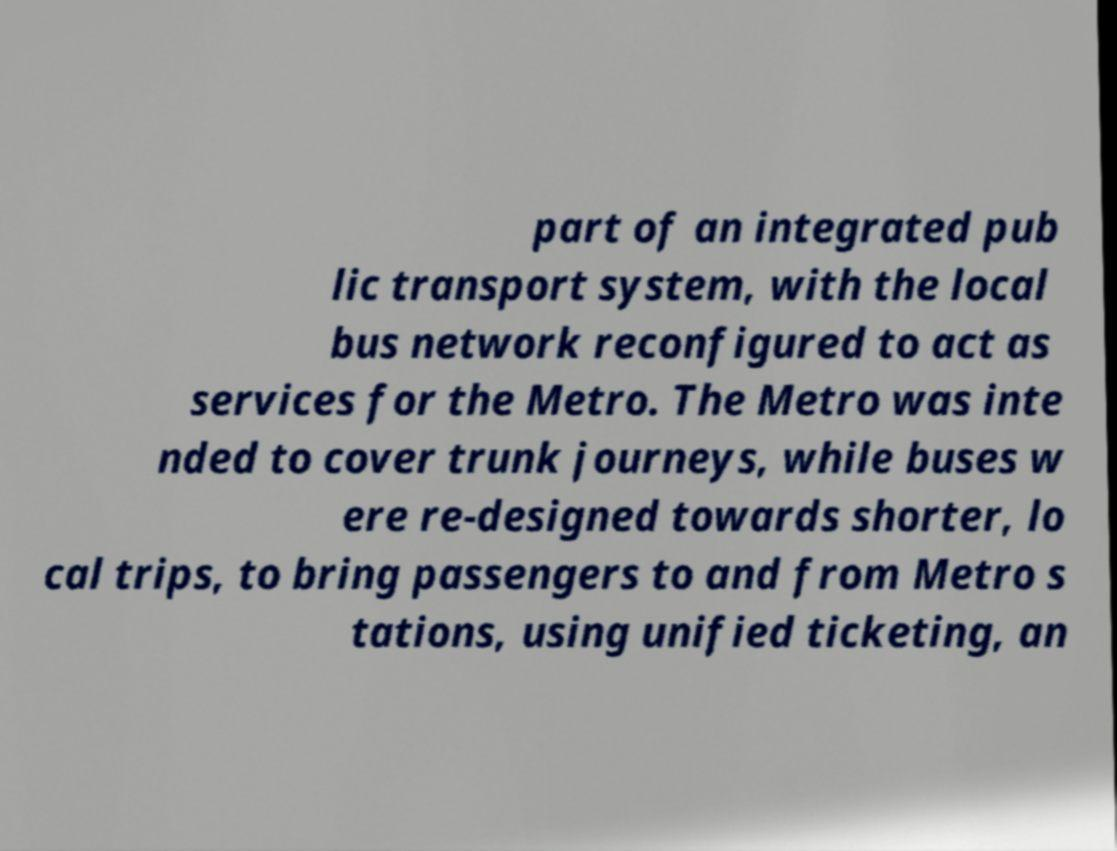There's text embedded in this image that I need extracted. Can you transcribe it verbatim? part of an integrated pub lic transport system, with the local bus network reconfigured to act as services for the Metro. The Metro was inte nded to cover trunk journeys, while buses w ere re-designed towards shorter, lo cal trips, to bring passengers to and from Metro s tations, using unified ticketing, an 